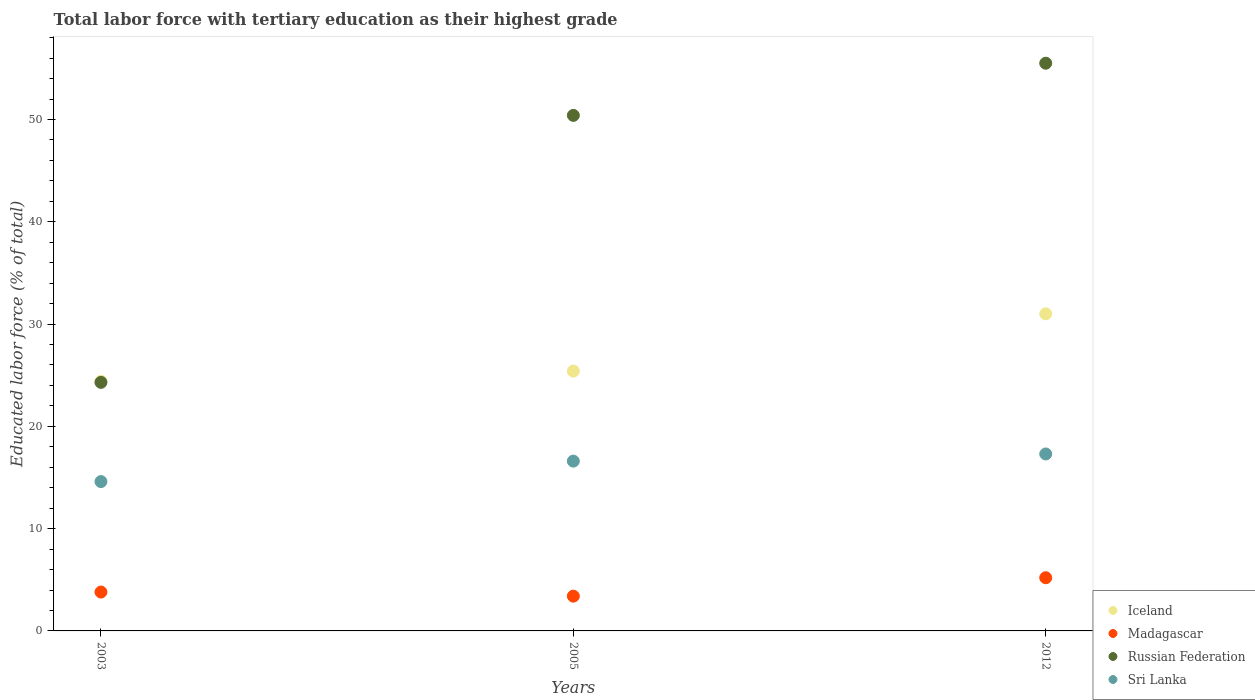Is the number of dotlines equal to the number of legend labels?
Make the answer very short. Yes. What is the percentage of male labor force with tertiary education in Madagascar in 2005?
Your answer should be compact. 3.4. Across all years, what is the maximum percentage of male labor force with tertiary education in Madagascar?
Make the answer very short. 5.2. Across all years, what is the minimum percentage of male labor force with tertiary education in Iceland?
Keep it short and to the point. 24.4. What is the total percentage of male labor force with tertiary education in Madagascar in the graph?
Keep it short and to the point. 12.4. What is the difference between the percentage of male labor force with tertiary education in Madagascar in 2003 and that in 2005?
Give a very brief answer. 0.4. What is the difference between the percentage of male labor force with tertiary education in Madagascar in 2005 and the percentage of male labor force with tertiary education in Iceland in 2012?
Your answer should be very brief. -27.6. What is the average percentage of male labor force with tertiary education in Iceland per year?
Your response must be concise. 26.93. In the year 2005, what is the difference between the percentage of male labor force with tertiary education in Madagascar and percentage of male labor force with tertiary education in Sri Lanka?
Your response must be concise. -13.2. What is the ratio of the percentage of male labor force with tertiary education in Iceland in 2005 to that in 2012?
Your answer should be compact. 0.82. What is the difference between the highest and the second highest percentage of male labor force with tertiary education in Iceland?
Offer a very short reply. 5.6. What is the difference between the highest and the lowest percentage of male labor force with tertiary education in Russian Federation?
Provide a succinct answer. 31.2. Is it the case that in every year, the sum of the percentage of male labor force with tertiary education in Sri Lanka and percentage of male labor force with tertiary education in Iceland  is greater than the percentage of male labor force with tertiary education in Madagascar?
Offer a very short reply. Yes. Does the percentage of male labor force with tertiary education in Russian Federation monotonically increase over the years?
Give a very brief answer. Yes. Is the percentage of male labor force with tertiary education in Madagascar strictly less than the percentage of male labor force with tertiary education in Russian Federation over the years?
Give a very brief answer. Yes. How many years are there in the graph?
Your answer should be compact. 3. What is the difference between two consecutive major ticks on the Y-axis?
Your answer should be compact. 10. Does the graph contain any zero values?
Ensure brevity in your answer.  No. Does the graph contain grids?
Give a very brief answer. No. How many legend labels are there?
Provide a short and direct response. 4. How are the legend labels stacked?
Provide a succinct answer. Vertical. What is the title of the graph?
Keep it short and to the point. Total labor force with tertiary education as their highest grade. Does "Azerbaijan" appear as one of the legend labels in the graph?
Your response must be concise. No. What is the label or title of the Y-axis?
Keep it short and to the point. Educated labor force (% of total). What is the Educated labor force (% of total) in Iceland in 2003?
Keep it short and to the point. 24.4. What is the Educated labor force (% of total) of Madagascar in 2003?
Your answer should be compact. 3.8. What is the Educated labor force (% of total) in Russian Federation in 2003?
Your answer should be very brief. 24.3. What is the Educated labor force (% of total) in Sri Lanka in 2003?
Your response must be concise. 14.6. What is the Educated labor force (% of total) in Iceland in 2005?
Provide a succinct answer. 25.4. What is the Educated labor force (% of total) of Madagascar in 2005?
Ensure brevity in your answer.  3.4. What is the Educated labor force (% of total) in Russian Federation in 2005?
Provide a succinct answer. 50.4. What is the Educated labor force (% of total) of Sri Lanka in 2005?
Keep it short and to the point. 16.6. What is the Educated labor force (% of total) in Iceland in 2012?
Your answer should be very brief. 31. What is the Educated labor force (% of total) in Madagascar in 2012?
Your response must be concise. 5.2. What is the Educated labor force (% of total) in Russian Federation in 2012?
Offer a terse response. 55.5. What is the Educated labor force (% of total) of Sri Lanka in 2012?
Offer a terse response. 17.3. Across all years, what is the maximum Educated labor force (% of total) of Madagascar?
Ensure brevity in your answer.  5.2. Across all years, what is the maximum Educated labor force (% of total) in Russian Federation?
Your answer should be compact. 55.5. Across all years, what is the maximum Educated labor force (% of total) of Sri Lanka?
Your response must be concise. 17.3. Across all years, what is the minimum Educated labor force (% of total) in Iceland?
Offer a terse response. 24.4. Across all years, what is the minimum Educated labor force (% of total) of Madagascar?
Your answer should be very brief. 3.4. Across all years, what is the minimum Educated labor force (% of total) of Russian Federation?
Your response must be concise. 24.3. Across all years, what is the minimum Educated labor force (% of total) of Sri Lanka?
Make the answer very short. 14.6. What is the total Educated labor force (% of total) in Iceland in the graph?
Make the answer very short. 80.8. What is the total Educated labor force (% of total) in Madagascar in the graph?
Ensure brevity in your answer.  12.4. What is the total Educated labor force (% of total) in Russian Federation in the graph?
Your answer should be very brief. 130.2. What is the total Educated labor force (% of total) in Sri Lanka in the graph?
Your answer should be compact. 48.5. What is the difference between the Educated labor force (% of total) of Russian Federation in 2003 and that in 2005?
Ensure brevity in your answer.  -26.1. What is the difference between the Educated labor force (% of total) of Iceland in 2003 and that in 2012?
Your answer should be compact. -6.6. What is the difference between the Educated labor force (% of total) of Madagascar in 2003 and that in 2012?
Your answer should be very brief. -1.4. What is the difference between the Educated labor force (% of total) of Russian Federation in 2003 and that in 2012?
Provide a succinct answer. -31.2. What is the difference between the Educated labor force (% of total) of Sri Lanka in 2003 and that in 2012?
Offer a very short reply. -2.7. What is the difference between the Educated labor force (% of total) of Iceland in 2005 and that in 2012?
Your answer should be compact. -5.6. What is the difference between the Educated labor force (% of total) in Russian Federation in 2005 and that in 2012?
Your response must be concise. -5.1. What is the difference between the Educated labor force (% of total) in Iceland in 2003 and the Educated labor force (% of total) in Madagascar in 2005?
Keep it short and to the point. 21. What is the difference between the Educated labor force (% of total) in Iceland in 2003 and the Educated labor force (% of total) in Russian Federation in 2005?
Keep it short and to the point. -26. What is the difference between the Educated labor force (% of total) of Iceland in 2003 and the Educated labor force (% of total) of Sri Lanka in 2005?
Offer a terse response. 7.8. What is the difference between the Educated labor force (% of total) of Madagascar in 2003 and the Educated labor force (% of total) of Russian Federation in 2005?
Make the answer very short. -46.6. What is the difference between the Educated labor force (% of total) in Russian Federation in 2003 and the Educated labor force (% of total) in Sri Lanka in 2005?
Provide a short and direct response. 7.7. What is the difference between the Educated labor force (% of total) of Iceland in 2003 and the Educated labor force (% of total) of Madagascar in 2012?
Offer a very short reply. 19.2. What is the difference between the Educated labor force (% of total) in Iceland in 2003 and the Educated labor force (% of total) in Russian Federation in 2012?
Give a very brief answer. -31.1. What is the difference between the Educated labor force (% of total) in Madagascar in 2003 and the Educated labor force (% of total) in Russian Federation in 2012?
Give a very brief answer. -51.7. What is the difference between the Educated labor force (% of total) of Russian Federation in 2003 and the Educated labor force (% of total) of Sri Lanka in 2012?
Give a very brief answer. 7. What is the difference between the Educated labor force (% of total) of Iceland in 2005 and the Educated labor force (% of total) of Madagascar in 2012?
Your answer should be very brief. 20.2. What is the difference between the Educated labor force (% of total) of Iceland in 2005 and the Educated labor force (% of total) of Russian Federation in 2012?
Provide a succinct answer. -30.1. What is the difference between the Educated labor force (% of total) of Iceland in 2005 and the Educated labor force (% of total) of Sri Lanka in 2012?
Your answer should be compact. 8.1. What is the difference between the Educated labor force (% of total) of Madagascar in 2005 and the Educated labor force (% of total) of Russian Federation in 2012?
Offer a very short reply. -52.1. What is the difference between the Educated labor force (% of total) in Russian Federation in 2005 and the Educated labor force (% of total) in Sri Lanka in 2012?
Make the answer very short. 33.1. What is the average Educated labor force (% of total) of Iceland per year?
Provide a short and direct response. 26.93. What is the average Educated labor force (% of total) of Madagascar per year?
Give a very brief answer. 4.13. What is the average Educated labor force (% of total) in Russian Federation per year?
Offer a very short reply. 43.4. What is the average Educated labor force (% of total) of Sri Lanka per year?
Your response must be concise. 16.17. In the year 2003, what is the difference between the Educated labor force (% of total) of Iceland and Educated labor force (% of total) of Madagascar?
Provide a succinct answer. 20.6. In the year 2003, what is the difference between the Educated labor force (% of total) in Iceland and Educated labor force (% of total) in Russian Federation?
Your response must be concise. 0.1. In the year 2003, what is the difference between the Educated labor force (% of total) in Iceland and Educated labor force (% of total) in Sri Lanka?
Offer a very short reply. 9.8. In the year 2003, what is the difference between the Educated labor force (% of total) in Madagascar and Educated labor force (% of total) in Russian Federation?
Ensure brevity in your answer.  -20.5. In the year 2003, what is the difference between the Educated labor force (% of total) of Russian Federation and Educated labor force (% of total) of Sri Lanka?
Give a very brief answer. 9.7. In the year 2005, what is the difference between the Educated labor force (% of total) in Iceland and Educated labor force (% of total) in Madagascar?
Provide a succinct answer. 22. In the year 2005, what is the difference between the Educated labor force (% of total) of Madagascar and Educated labor force (% of total) of Russian Federation?
Provide a short and direct response. -47. In the year 2005, what is the difference between the Educated labor force (% of total) in Madagascar and Educated labor force (% of total) in Sri Lanka?
Keep it short and to the point. -13.2. In the year 2005, what is the difference between the Educated labor force (% of total) of Russian Federation and Educated labor force (% of total) of Sri Lanka?
Provide a short and direct response. 33.8. In the year 2012, what is the difference between the Educated labor force (% of total) of Iceland and Educated labor force (% of total) of Madagascar?
Ensure brevity in your answer.  25.8. In the year 2012, what is the difference between the Educated labor force (% of total) of Iceland and Educated labor force (% of total) of Russian Federation?
Give a very brief answer. -24.5. In the year 2012, what is the difference between the Educated labor force (% of total) of Iceland and Educated labor force (% of total) of Sri Lanka?
Keep it short and to the point. 13.7. In the year 2012, what is the difference between the Educated labor force (% of total) in Madagascar and Educated labor force (% of total) in Russian Federation?
Give a very brief answer. -50.3. In the year 2012, what is the difference between the Educated labor force (% of total) in Madagascar and Educated labor force (% of total) in Sri Lanka?
Your response must be concise. -12.1. In the year 2012, what is the difference between the Educated labor force (% of total) in Russian Federation and Educated labor force (% of total) in Sri Lanka?
Keep it short and to the point. 38.2. What is the ratio of the Educated labor force (% of total) of Iceland in 2003 to that in 2005?
Keep it short and to the point. 0.96. What is the ratio of the Educated labor force (% of total) of Madagascar in 2003 to that in 2005?
Give a very brief answer. 1.12. What is the ratio of the Educated labor force (% of total) in Russian Federation in 2003 to that in 2005?
Keep it short and to the point. 0.48. What is the ratio of the Educated labor force (% of total) of Sri Lanka in 2003 to that in 2005?
Give a very brief answer. 0.88. What is the ratio of the Educated labor force (% of total) of Iceland in 2003 to that in 2012?
Give a very brief answer. 0.79. What is the ratio of the Educated labor force (% of total) of Madagascar in 2003 to that in 2012?
Offer a terse response. 0.73. What is the ratio of the Educated labor force (% of total) of Russian Federation in 2003 to that in 2012?
Your answer should be very brief. 0.44. What is the ratio of the Educated labor force (% of total) of Sri Lanka in 2003 to that in 2012?
Give a very brief answer. 0.84. What is the ratio of the Educated labor force (% of total) of Iceland in 2005 to that in 2012?
Keep it short and to the point. 0.82. What is the ratio of the Educated labor force (% of total) of Madagascar in 2005 to that in 2012?
Ensure brevity in your answer.  0.65. What is the ratio of the Educated labor force (% of total) in Russian Federation in 2005 to that in 2012?
Offer a very short reply. 0.91. What is the ratio of the Educated labor force (% of total) in Sri Lanka in 2005 to that in 2012?
Make the answer very short. 0.96. What is the difference between the highest and the second highest Educated labor force (% of total) in Iceland?
Provide a short and direct response. 5.6. What is the difference between the highest and the second highest Educated labor force (% of total) in Russian Federation?
Keep it short and to the point. 5.1. What is the difference between the highest and the second highest Educated labor force (% of total) in Sri Lanka?
Ensure brevity in your answer.  0.7. What is the difference between the highest and the lowest Educated labor force (% of total) in Russian Federation?
Offer a very short reply. 31.2. 